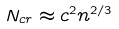<formula> <loc_0><loc_0><loc_500><loc_500>N _ { c r } \approx c ^ { 2 } n ^ { 2 / 3 }</formula> 